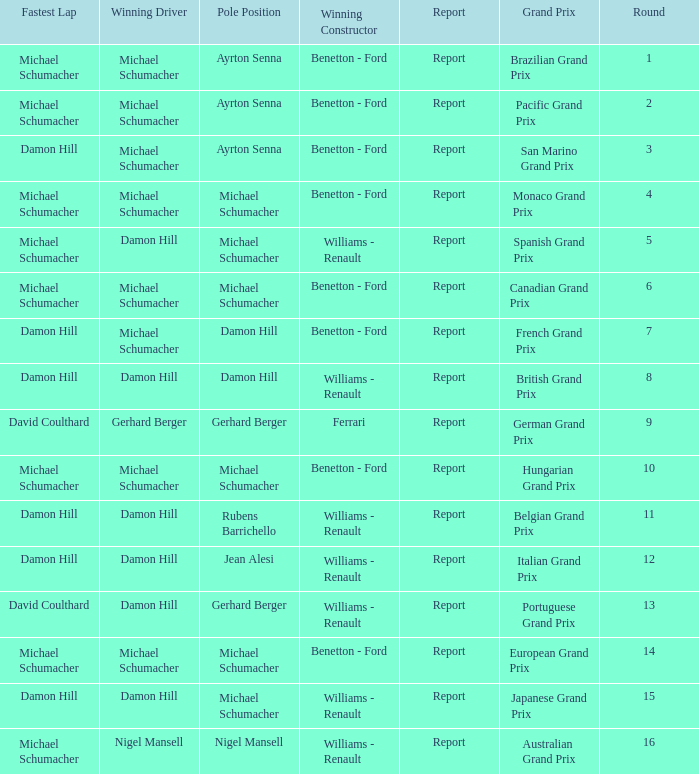Name the fastest lap for the brazilian grand prix Michael Schumacher. Could you parse the entire table as a dict? {'header': ['Fastest Lap', 'Winning Driver', 'Pole Position', 'Winning Constructor', 'Report', 'Grand Prix', 'Round'], 'rows': [['Michael Schumacher', 'Michael Schumacher', 'Ayrton Senna', 'Benetton - Ford', 'Report', 'Brazilian Grand Prix', '1'], ['Michael Schumacher', 'Michael Schumacher', 'Ayrton Senna', 'Benetton - Ford', 'Report', 'Pacific Grand Prix', '2'], ['Damon Hill', 'Michael Schumacher', 'Ayrton Senna', 'Benetton - Ford', 'Report', 'San Marino Grand Prix', '3'], ['Michael Schumacher', 'Michael Schumacher', 'Michael Schumacher', 'Benetton - Ford', 'Report', 'Monaco Grand Prix', '4'], ['Michael Schumacher', 'Damon Hill', 'Michael Schumacher', 'Williams - Renault', 'Report', 'Spanish Grand Prix', '5'], ['Michael Schumacher', 'Michael Schumacher', 'Michael Schumacher', 'Benetton - Ford', 'Report', 'Canadian Grand Prix', '6'], ['Damon Hill', 'Michael Schumacher', 'Damon Hill', 'Benetton - Ford', 'Report', 'French Grand Prix', '7'], ['Damon Hill', 'Damon Hill', 'Damon Hill', 'Williams - Renault', 'Report', 'British Grand Prix', '8'], ['David Coulthard', 'Gerhard Berger', 'Gerhard Berger', 'Ferrari', 'Report', 'German Grand Prix', '9'], ['Michael Schumacher', 'Michael Schumacher', 'Michael Schumacher', 'Benetton - Ford', 'Report', 'Hungarian Grand Prix', '10'], ['Damon Hill', 'Damon Hill', 'Rubens Barrichello', 'Williams - Renault', 'Report', 'Belgian Grand Prix', '11'], ['Damon Hill', 'Damon Hill', 'Jean Alesi', 'Williams - Renault', 'Report', 'Italian Grand Prix', '12'], ['David Coulthard', 'Damon Hill', 'Gerhard Berger', 'Williams - Renault', 'Report', 'Portuguese Grand Prix', '13'], ['Michael Schumacher', 'Michael Schumacher', 'Michael Schumacher', 'Benetton - Ford', 'Report', 'European Grand Prix', '14'], ['Damon Hill', 'Damon Hill', 'Michael Schumacher', 'Williams - Renault', 'Report', 'Japanese Grand Prix', '15'], ['Michael Schumacher', 'Nigel Mansell', 'Nigel Mansell', 'Williams - Renault', 'Report', 'Australian Grand Prix', '16']]} 